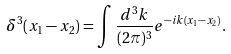Convert formula to latex. <formula><loc_0><loc_0><loc_500><loc_500>\delta ^ { 3 } ( x _ { 1 } - x _ { 2 } ) = \int \frac { d ^ { 3 } k } { ( 2 \pi ) ^ { 3 } } e ^ { - i k ( x _ { 1 } - x _ { 2 } ) } .</formula> 